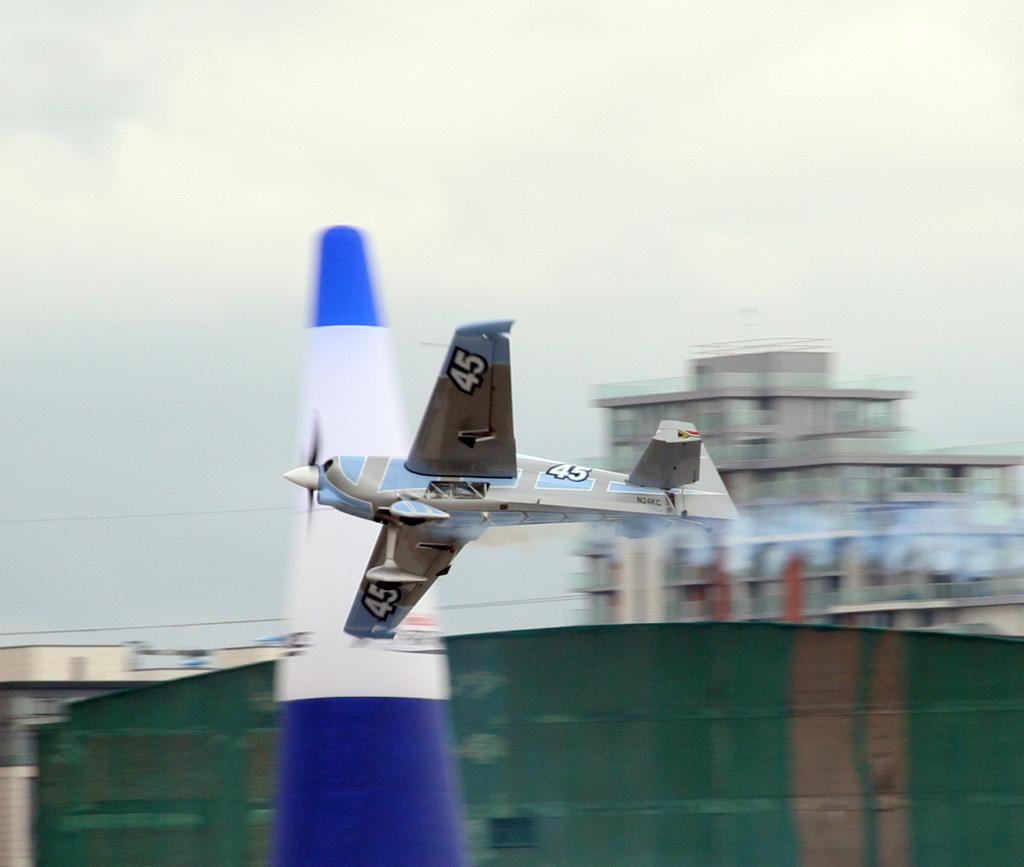<image>
Summarize the visual content of the image. A model air plane with the number 45 on the bottom of both wings, is flying through the air. 